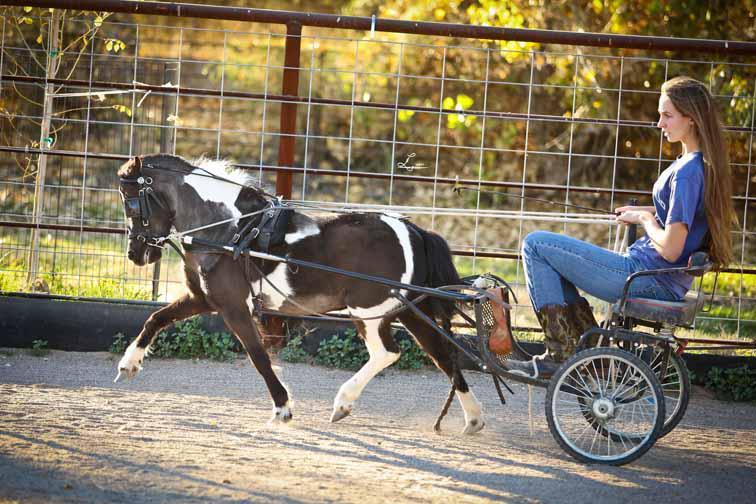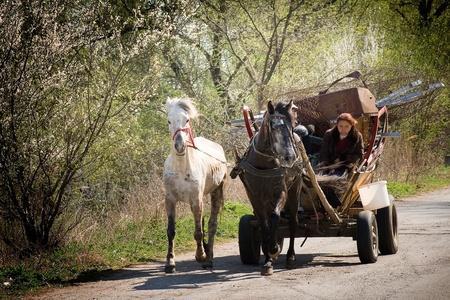The first image is the image on the left, the second image is the image on the right. Analyze the images presented: Is the assertion "On each picture, there is a single horse pulling a cart." valid? Answer yes or no. No. The first image is the image on the left, the second image is the image on the right. For the images shown, is this caption "An image shows a four-wheeled wagon pulled by more than one horse." true? Answer yes or no. Yes. 